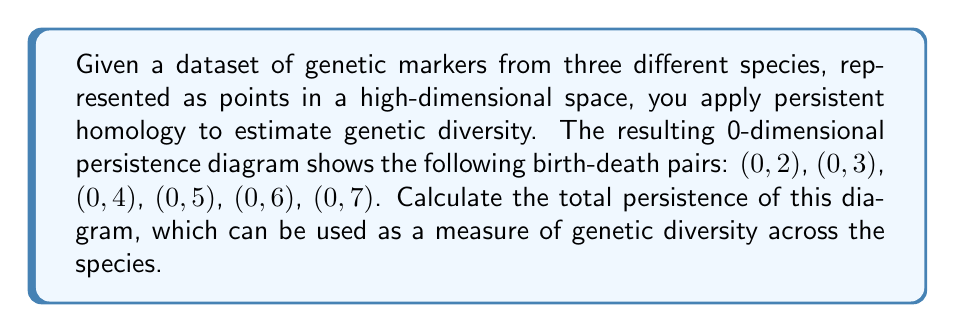Can you answer this question? To calculate the total persistence of the 0-dimensional persistence diagram, we'll follow these steps:

1) The total persistence is defined as the sum of all persistence values.

2) For each birth-death pair $(b_i, d_i)$, the persistence is calculated as $d_i - b_i$.

3) In this case, all birth times are 0, so the persistence for each pair is simply the death time.

4) Let's calculate the persistence for each pair:
   $(0,2)$: $2-0 = 2$
   $(0,3)$: $3-0 = 3$
   $(0,4)$: $4-0 = 4$
   $(0,5)$: $5-0 = 5$
   $(0,6)$: $6-0 = 6$
   $(0,7)$: $7-0 = 7$

5) Now, we sum all these persistence values:

   $$\text{Total Persistence} = 2 + 3 + 4 + 5 + 6 + 7 = 27$$

This total persistence value of 27 provides a measure of the genetic diversity across the three species, with higher values indicating greater diversity.
Answer: $$27$$ 